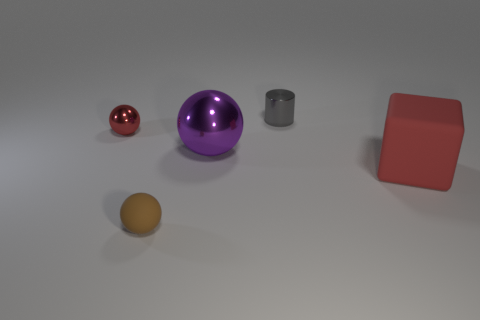Is the number of red metallic things greater than the number of small metallic things? Upon examining the image, it appears there is one small red metallic sphere. In terms of small metallic things overall, we have the red sphere and a silver cylindrical object. Since both count as small metallic objects and only one of them is red, the number of small metallic things is not greater than the number of red metallic things; they are equal in quantity. Each category consists of a single item. 